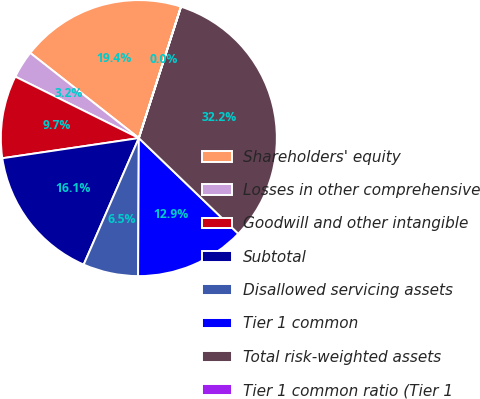Convert chart. <chart><loc_0><loc_0><loc_500><loc_500><pie_chart><fcel>Shareholders' equity<fcel>Losses in other comprehensive<fcel>Goodwill and other intangible<fcel>Subtotal<fcel>Disallowed servicing assets<fcel>Tier 1 common<fcel>Total risk-weighted assets<fcel>Tier 1 common ratio (Tier 1<nl><fcel>19.35%<fcel>3.24%<fcel>9.68%<fcel>16.12%<fcel>6.46%<fcel>12.9%<fcel>32.24%<fcel>0.01%<nl></chart> 